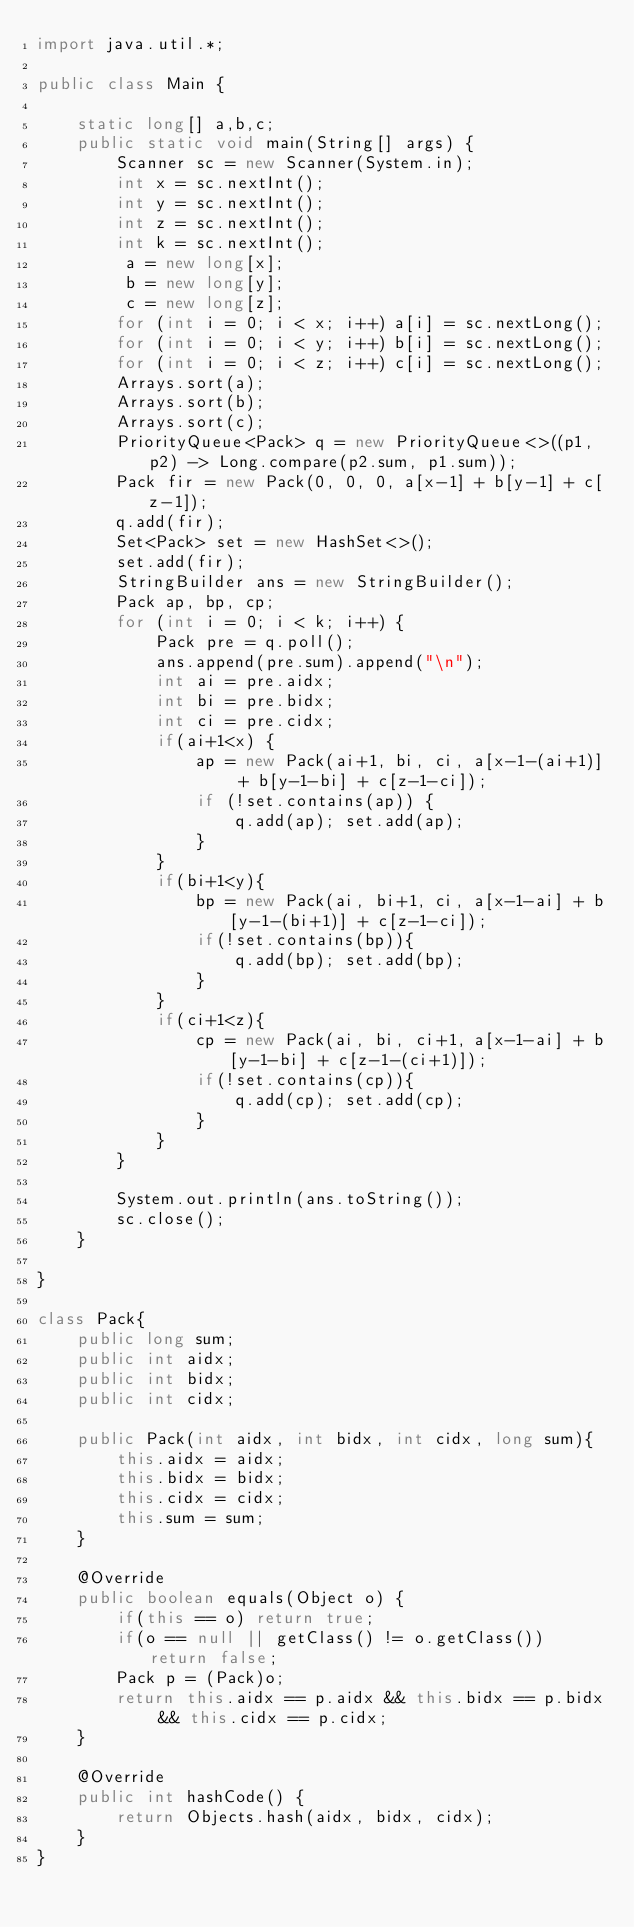Convert code to text. <code><loc_0><loc_0><loc_500><loc_500><_Java_>import java.util.*;

public class Main {

    static long[] a,b,c;
    public static void main(String[] args) {
        Scanner sc = new Scanner(System.in);
        int x = sc.nextInt();
        int y = sc.nextInt();
        int z = sc.nextInt();
        int k = sc.nextInt();
         a = new long[x];
         b = new long[y];
         c = new long[z];
        for (int i = 0; i < x; i++) a[i] = sc.nextLong();
        for (int i = 0; i < y; i++) b[i] = sc.nextLong();
        for (int i = 0; i < z; i++) c[i] = sc.nextLong();
        Arrays.sort(a);
        Arrays.sort(b);
        Arrays.sort(c);
        PriorityQueue<Pack> q = new PriorityQueue<>((p1,p2) -> Long.compare(p2.sum, p1.sum));
        Pack fir = new Pack(0, 0, 0, a[x-1] + b[y-1] + c[z-1]);
        q.add(fir);
        Set<Pack> set = new HashSet<>();
        set.add(fir);
        StringBuilder ans = new StringBuilder();
        Pack ap, bp, cp;
        for (int i = 0; i < k; i++) {
            Pack pre = q.poll();
            ans.append(pre.sum).append("\n");
            int ai = pre.aidx;
            int bi = pre.bidx;
            int ci = pre.cidx;
            if(ai+1<x) {
                ap = new Pack(ai+1, bi, ci, a[x-1-(ai+1)] + b[y-1-bi] + c[z-1-ci]);
                if (!set.contains(ap)) {
                    q.add(ap); set.add(ap);
                }
            }
            if(bi+1<y){
                bp = new Pack(ai, bi+1, ci, a[x-1-ai] + b[y-1-(bi+1)] + c[z-1-ci]);
                if(!set.contains(bp)){
                    q.add(bp); set.add(bp);
                }
            }
            if(ci+1<z){
                cp = new Pack(ai, bi, ci+1, a[x-1-ai] + b[y-1-bi] + c[z-1-(ci+1)]);
                if(!set.contains(cp)){
                    q.add(cp); set.add(cp);
                }
            }
        }

        System.out.println(ans.toString());
        sc.close();
    }

}

class Pack{
    public long sum;
    public int aidx;
    public int bidx;
    public int cidx;

    public Pack(int aidx, int bidx, int cidx, long sum){
        this.aidx = aidx;
        this.bidx = bidx;
        this.cidx = cidx;
        this.sum = sum;
    }

    @Override
    public boolean equals(Object o) {
        if(this == o) return true;
        if(o == null || getClass() != o.getClass()) return false;
        Pack p = (Pack)o;
        return this.aidx == p.aidx && this.bidx == p.bidx && this.cidx == p.cidx;
    }

    @Override
    public int hashCode() {
        return Objects.hash(aidx, bidx, cidx);
    }
}
</code> 